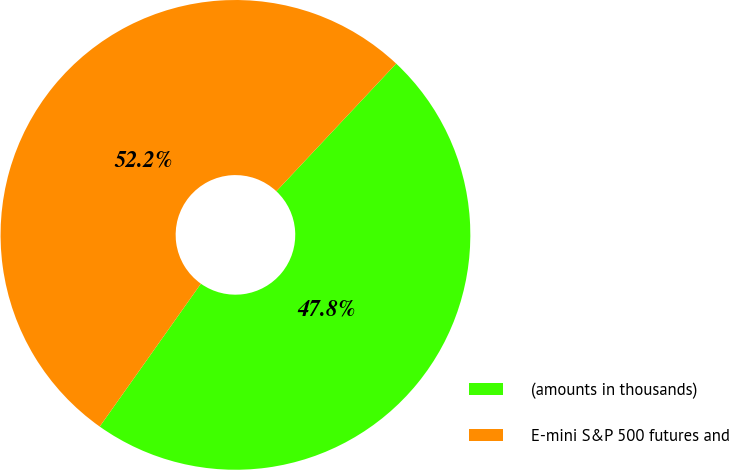Convert chart. <chart><loc_0><loc_0><loc_500><loc_500><pie_chart><fcel>(amounts in thousands)<fcel>E-mini S&P 500 futures and<nl><fcel>47.81%<fcel>52.19%<nl></chart> 